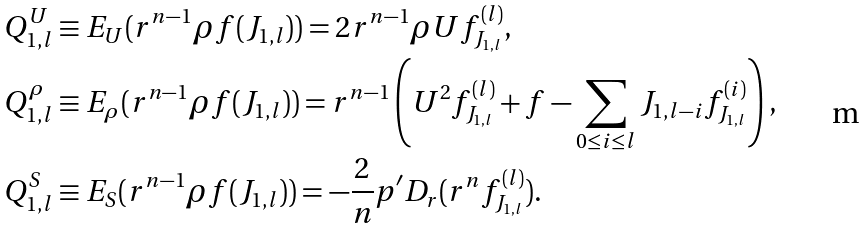Convert formula to latex. <formula><loc_0><loc_0><loc_500><loc_500>& Q ^ { U } _ { 1 , l } \equiv E _ { U } ( r ^ { n - 1 } \rho f ( J _ { 1 , l } ) ) = 2 r ^ { n - 1 } \rho U f _ { J _ { 1 , l } } ^ { ( l ) } , \\ & Q ^ { \rho } _ { 1 , l } \equiv E _ { \rho } ( r ^ { n - 1 } \rho f ( J _ { 1 , l } ) ) = r ^ { n - 1 } \left ( U ^ { 2 } f _ { J _ { 1 , l } } ^ { ( l ) } + f - \sum _ { 0 \leq i \leq l } J _ { 1 , l - i } f _ { J _ { 1 , l } } ^ { ( i ) } \right ) , \\ & Q ^ { S } _ { 1 , l } \equiv E _ { S } ( r ^ { n - 1 } \rho f ( J _ { 1 , l } ) ) = - \frac { 2 } { n } p ^ { \prime } D _ { r } ( r ^ { n } f _ { J _ { 1 , l } } ^ { ( l ) } ) .</formula> 